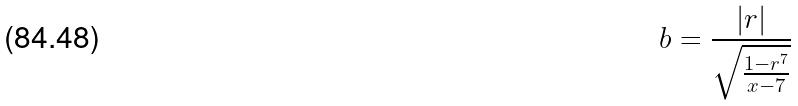<formula> <loc_0><loc_0><loc_500><loc_500>b = \frac { | r | } { \sqrt { \frac { 1 - r ^ { 7 } } { x - 7 } } }</formula> 